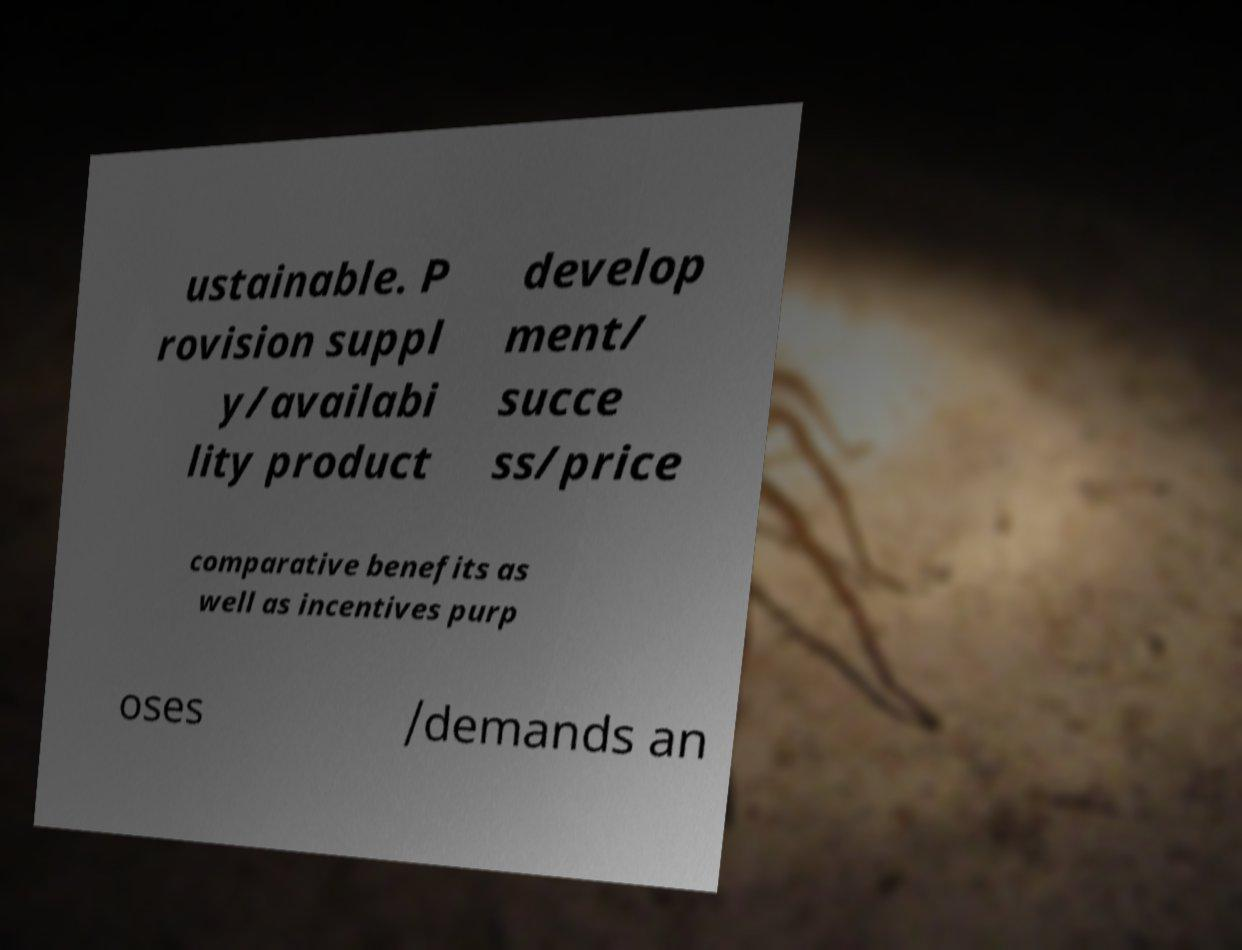For documentation purposes, I need the text within this image transcribed. Could you provide that? ustainable. P rovision suppl y/availabi lity product develop ment/ succe ss/price comparative benefits as well as incentives purp oses /demands an 